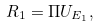Convert formula to latex. <formula><loc_0><loc_0><loc_500><loc_500>R _ { 1 } = \Pi U _ { E _ { 1 } } ,</formula> 